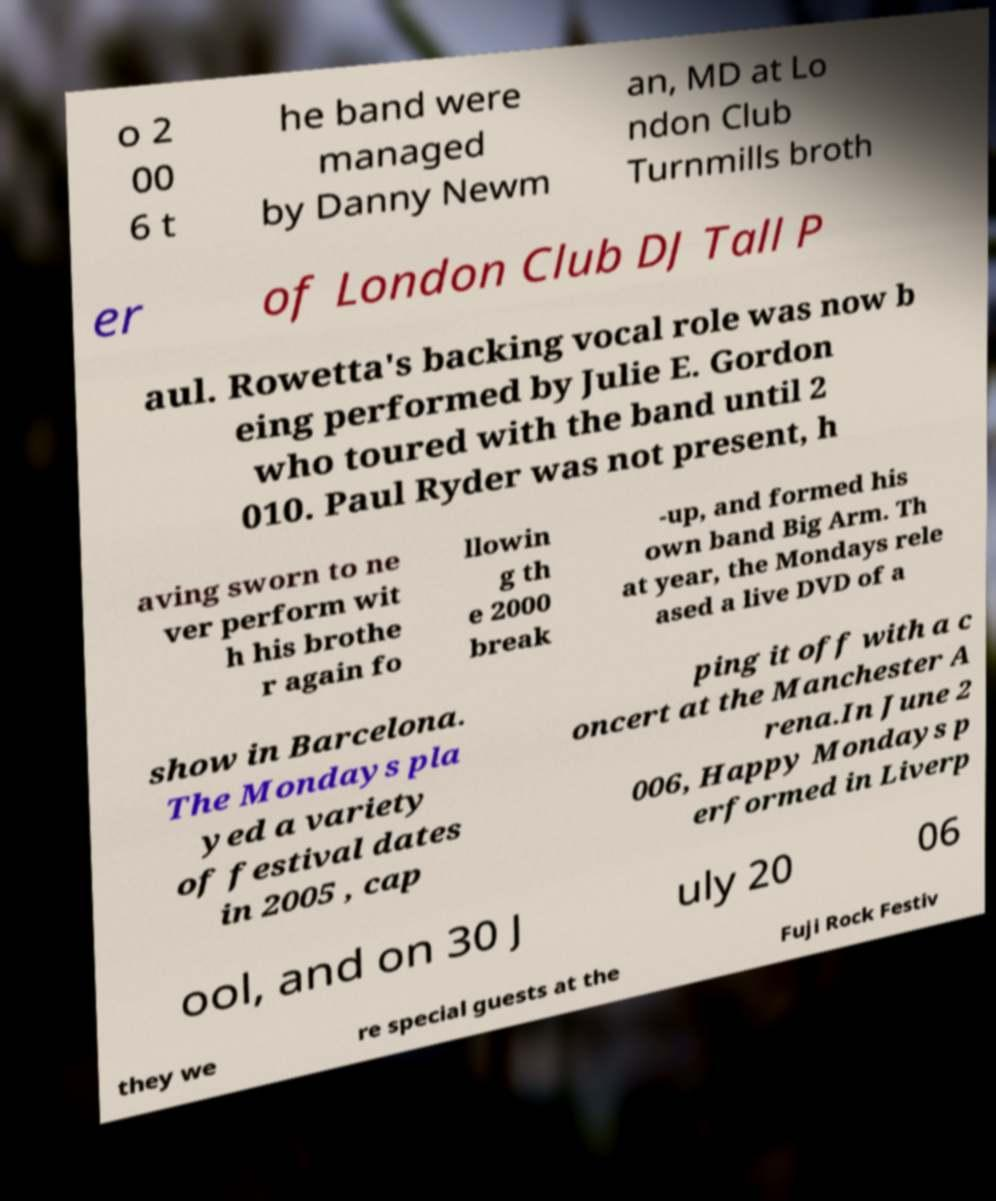Can you read and provide the text displayed in the image?This photo seems to have some interesting text. Can you extract and type it out for me? o 2 00 6 t he band were managed by Danny Newm an, MD at Lo ndon Club Turnmills broth er of London Club DJ Tall P aul. Rowetta's backing vocal role was now b eing performed by Julie E. Gordon who toured with the band until 2 010. Paul Ryder was not present, h aving sworn to ne ver perform wit h his brothe r again fo llowin g th e 2000 break -up, and formed his own band Big Arm. Th at year, the Mondays rele ased a live DVD of a show in Barcelona. The Mondays pla yed a variety of festival dates in 2005 , cap ping it off with a c oncert at the Manchester A rena.In June 2 006, Happy Mondays p erformed in Liverp ool, and on 30 J uly 20 06 they we re special guests at the Fuji Rock Festiv 